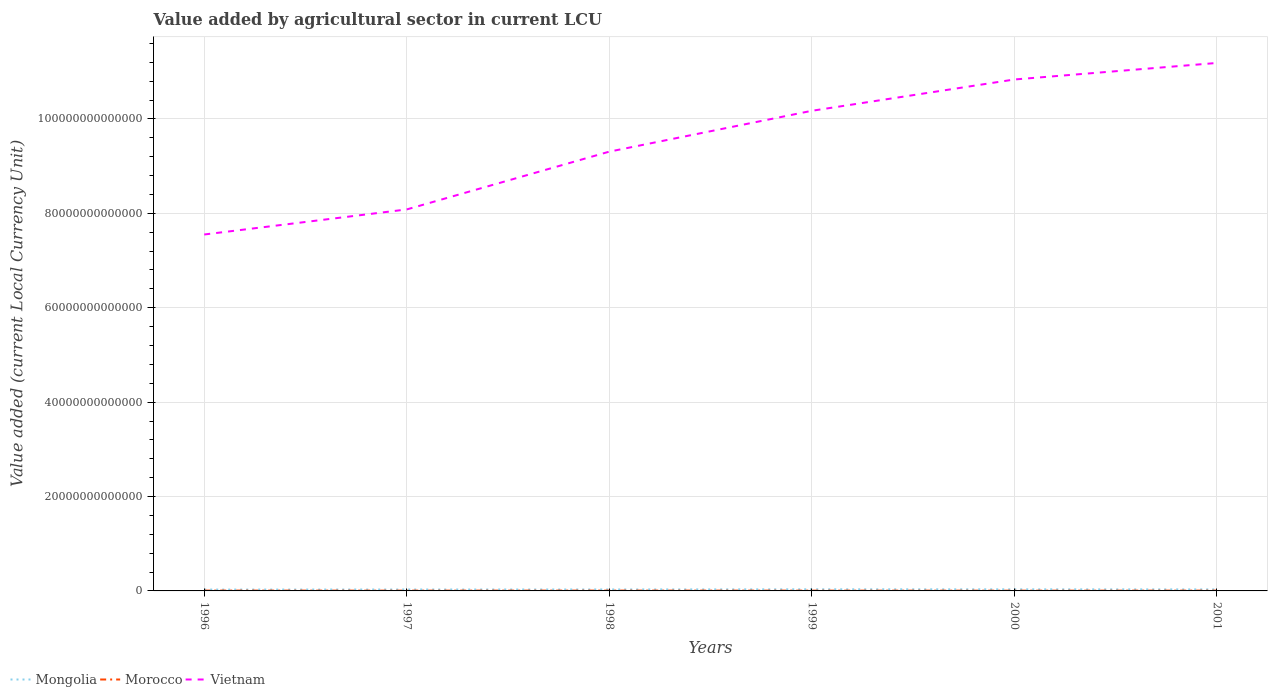Is the number of lines equal to the number of legend labels?
Ensure brevity in your answer.  Yes. Across all years, what is the maximum value added by agricultural sector in Vietnam?
Your response must be concise. 7.55e+13. What is the total value added by agricultural sector in Morocco in the graph?
Your answer should be compact. -4.54e+09. What is the difference between the highest and the second highest value added by agricultural sector in Mongolia?
Ensure brevity in your answer.  5.85e+1. How many lines are there?
Ensure brevity in your answer.  3. How many years are there in the graph?
Give a very brief answer. 6. What is the difference between two consecutive major ticks on the Y-axis?
Ensure brevity in your answer.  2.00e+13. Are the values on the major ticks of Y-axis written in scientific E-notation?
Your answer should be compact. No. Does the graph contain grids?
Offer a terse response. Yes. Where does the legend appear in the graph?
Provide a succinct answer. Bottom left. How many legend labels are there?
Keep it short and to the point. 3. How are the legend labels stacked?
Your answer should be very brief. Horizontal. What is the title of the graph?
Offer a very short reply. Value added by agricultural sector in current LCU. Does "Solomon Islands" appear as one of the legend labels in the graph?
Offer a terse response. No. What is the label or title of the Y-axis?
Your response must be concise. Value added (current Local Currency Unit). What is the Value added (current Local Currency Unit) in Mongolia in 1996?
Make the answer very short. 2.84e+11. What is the Value added (current Local Currency Unit) in Morocco in 1996?
Offer a very short reply. 7.09e+1. What is the Value added (current Local Currency Unit) of Vietnam in 1996?
Provide a succinct answer. 7.55e+13. What is the Value added (current Local Currency Unit) in Mongolia in 1997?
Provide a short and direct response. 3.01e+11. What is the Value added (current Local Currency Unit) of Morocco in 1997?
Your answer should be compact. 5.81e+1. What is the Value added (current Local Currency Unit) in Vietnam in 1997?
Provide a succinct answer. 8.08e+13. What is the Value added (current Local Currency Unit) of Mongolia in 1998?
Provide a short and direct response. 3.07e+11. What is the Value added (current Local Currency Unit) in Morocco in 1998?
Provide a short and direct response. 6.89e+1. What is the Value added (current Local Currency Unit) of Vietnam in 1998?
Your response must be concise. 9.31e+13. What is the Value added (current Local Currency Unit) in Mongolia in 1999?
Your answer should be very brief. 3.43e+11. What is the Value added (current Local Currency Unit) of Morocco in 1999?
Give a very brief answer. 6.03e+1. What is the Value added (current Local Currency Unit) of Vietnam in 1999?
Your answer should be very brief. 1.02e+14. What is the Value added (current Local Currency Unit) in Mongolia in 2000?
Give a very brief answer. 3.36e+11. What is the Value added (current Local Currency Unit) in Morocco in 2000?
Provide a succinct answer. 5.22e+1. What is the Value added (current Local Currency Unit) in Vietnam in 2000?
Ensure brevity in your answer.  1.08e+14. What is the Value added (current Local Currency Unit) of Mongolia in 2001?
Keep it short and to the point. 3.20e+11. What is the Value added (current Local Currency Unit) of Morocco in 2001?
Your response must be concise. 6.27e+1. What is the Value added (current Local Currency Unit) in Vietnam in 2001?
Provide a short and direct response. 1.12e+14. Across all years, what is the maximum Value added (current Local Currency Unit) of Mongolia?
Make the answer very short. 3.43e+11. Across all years, what is the maximum Value added (current Local Currency Unit) in Morocco?
Ensure brevity in your answer.  7.09e+1. Across all years, what is the maximum Value added (current Local Currency Unit) in Vietnam?
Offer a very short reply. 1.12e+14. Across all years, what is the minimum Value added (current Local Currency Unit) of Mongolia?
Make the answer very short. 2.84e+11. Across all years, what is the minimum Value added (current Local Currency Unit) of Morocco?
Offer a terse response. 5.22e+1. Across all years, what is the minimum Value added (current Local Currency Unit) of Vietnam?
Give a very brief answer. 7.55e+13. What is the total Value added (current Local Currency Unit) of Mongolia in the graph?
Offer a terse response. 1.89e+12. What is the total Value added (current Local Currency Unit) in Morocco in the graph?
Keep it short and to the point. 3.73e+11. What is the total Value added (current Local Currency Unit) of Vietnam in the graph?
Provide a short and direct response. 5.71e+14. What is the difference between the Value added (current Local Currency Unit) in Mongolia in 1996 and that in 1997?
Offer a very short reply. -1.68e+1. What is the difference between the Value added (current Local Currency Unit) of Morocco in 1996 and that in 1997?
Offer a terse response. 1.28e+1. What is the difference between the Value added (current Local Currency Unit) of Vietnam in 1996 and that in 1997?
Offer a terse response. -5.31e+12. What is the difference between the Value added (current Local Currency Unit) of Mongolia in 1996 and that in 1998?
Your answer should be compact. -2.27e+1. What is the difference between the Value added (current Local Currency Unit) of Morocco in 1996 and that in 1998?
Give a very brief answer. 1.99e+09. What is the difference between the Value added (current Local Currency Unit) of Vietnam in 1996 and that in 1998?
Make the answer very short. -1.76e+13. What is the difference between the Value added (current Local Currency Unit) in Mongolia in 1996 and that in 1999?
Your answer should be compact. -5.85e+1. What is the difference between the Value added (current Local Currency Unit) in Morocco in 1996 and that in 1999?
Keep it short and to the point. 1.06e+1. What is the difference between the Value added (current Local Currency Unit) in Vietnam in 1996 and that in 1999?
Your answer should be very brief. -2.62e+13. What is the difference between the Value added (current Local Currency Unit) of Mongolia in 1996 and that in 2000?
Provide a short and direct response. -5.17e+1. What is the difference between the Value added (current Local Currency Unit) in Morocco in 1996 and that in 2000?
Provide a succinct answer. 1.87e+1. What is the difference between the Value added (current Local Currency Unit) of Vietnam in 1996 and that in 2000?
Make the answer very short. -3.28e+13. What is the difference between the Value added (current Local Currency Unit) of Mongolia in 1996 and that in 2001?
Offer a terse response. -3.57e+1. What is the difference between the Value added (current Local Currency Unit) of Morocco in 1996 and that in 2001?
Offer a terse response. 8.23e+09. What is the difference between the Value added (current Local Currency Unit) of Vietnam in 1996 and that in 2001?
Offer a terse response. -3.63e+13. What is the difference between the Value added (current Local Currency Unit) in Mongolia in 1997 and that in 1998?
Your response must be concise. -5.90e+09. What is the difference between the Value added (current Local Currency Unit) of Morocco in 1997 and that in 1998?
Make the answer very short. -1.08e+1. What is the difference between the Value added (current Local Currency Unit) in Vietnam in 1997 and that in 1998?
Your answer should be compact. -1.22e+13. What is the difference between the Value added (current Local Currency Unit) in Mongolia in 1997 and that in 1999?
Give a very brief answer. -4.18e+1. What is the difference between the Value added (current Local Currency Unit) of Morocco in 1997 and that in 1999?
Make the answer very short. -2.15e+09. What is the difference between the Value added (current Local Currency Unit) in Vietnam in 1997 and that in 1999?
Your answer should be very brief. -2.09e+13. What is the difference between the Value added (current Local Currency Unit) of Mongolia in 1997 and that in 2000?
Give a very brief answer. -3.49e+1. What is the difference between the Value added (current Local Currency Unit) of Morocco in 1997 and that in 2000?
Ensure brevity in your answer.  5.90e+09. What is the difference between the Value added (current Local Currency Unit) of Vietnam in 1997 and that in 2000?
Offer a very short reply. -2.75e+13. What is the difference between the Value added (current Local Currency Unit) of Mongolia in 1997 and that in 2001?
Offer a very short reply. -1.90e+1. What is the difference between the Value added (current Local Currency Unit) of Morocco in 1997 and that in 2001?
Your answer should be very brief. -4.54e+09. What is the difference between the Value added (current Local Currency Unit) of Vietnam in 1997 and that in 2001?
Your answer should be very brief. -3.10e+13. What is the difference between the Value added (current Local Currency Unit) of Mongolia in 1998 and that in 1999?
Ensure brevity in your answer.  -3.59e+1. What is the difference between the Value added (current Local Currency Unit) of Morocco in 1998 and that in 1999?
Offer a terse response. 8.63e+09. What is the difference between the Value added (current Local Currency Unit) of Vietnam in 1998 and that in 1999?
Ensure brevity in your answer.  -8.66e+12. What is the difference between the Value added (current Local Currency Unit) in Mongolia in 1998 and that in 2000?
Your response must be concise. -2.90e+1. What is the difference between the Value added (current Local Currency Unit) of Morocco in 1998 and that in 2000?
Your answer should be very brief. 1.67e+1. What is the difference between the Value added (current Local Currency Unit) of Vietnam in 1998 and that in 2000?
Keep it short and to the point. -1.53e+13. What is the difference between the Value added (current Local Currency Unit) of Mongolia in 1998 and that in 2001?
Provide a short and direct response. -1.31e+1. What is the difference between the Value added (current Local Currency Unit) in Morocco in 1998 and that in 2001?
Your answer should be compact. 6.24e+09. What is the difference between the Value added (current Local Currency Unit) of Vietnam in 1998 and that in 2001?
Offer a terse response. -1.88e+13. What is the difference between the Value added (current Local Currency Unit) of Mongolia in 1999 and that in 2000?
Provide a short and direct response. 6.84e+09. What is the difference between the Value added (current Local Currency Unit) of Morocco in 1999 and that in 2000?
Your answer should be very brief. 8.05e+09. What is the difference between the Value added (current Local Currency Unit) of Vietnam in 1999 and that in 2000?
Your response must be concise. -6.63e+12. What is the difference between the Value added (current Local Currency Unit) of Mongolia in 1999 and that in 2001?
Provide a succinct answer. 2.28e+1. What is the difference between the Value added (current Local Currency Unit) of Morocco in 1999 and that in 2001?
Offer a terse response. -2.39e+09. What is the difference between the Value added (current Local Currency Unit) of Vietnam in 1999 and that in 2001?
Keep it short and to the point. -1.01e+13. What is the difference between the Value added (current Local Currency Unit) in Mongolia in 2000 and that in 2001?
Provide a short and direct response. 1.60e+1. What is the difference between the Value added (current Local Currency Unit) of Morocco in 2000 and that in 2001?
Provide a succinct answer. -1.04e+1. What is the difference between the Value added (current Local Currency Unit) in Vietnam in 2000 and that in 2001?
Make the answer very short. -3.50e+12. What is the difference between the Value added (current Local Currency Unit) of Mongolia in 1996 and the Value added (current Local Currency Unit) of Morocco in 1997?
Make the answer very short. 2.26e+11. What is the difference between the Value added (current Local Currency Unit) in Mongolia in 1996 and the Value added (current Local Currency Unit) in Vietnam in 1997?
Your answer should be compact. -8.05e+13. What is the difference between the Value added (current Local Currency Unit) of Morocco in 1996 and the Value added (current Local Currency Unit) of Vietnam in 1997?
Ensure brevity in your answer.  -8.08e+13. What is the difference between the Value added (current Local Currency Unit) of Mongolia in 1996 and the Value added (current Local Currency Unit) of Morocco in 1998?
Offer a terse response. 2.15e+11. What is the difference between the Value added (current Local Currency Unit) in Mongolia in 1996 and the Value added (current Local Currency Unit) in Vietnam in 1998?
Provide a succinct answer. -9.28e+13. What is the difference between the Value added (current Local Currency Unit) of Morocco in 1996 and the Value added (current Local Currency Unit) of Vietnam in 1998?
Offer a terse response. -9.30e+13. What is the difference between the Value added (current Local Currency Unit) of Mongolia in 1996 and the Value added (current Local Currency Unit) of Morocco in 1999?
Make the answer very short. 2.24e+11. What is the difference between the Value added (current Local Currency Unit) of Mongolia in 1996 and the Value added (current Local Currency Unit) of Vietnam in 1999?
Your response must be concise. -1.01e+14. What is the difference between the Value added (current Local Currency Unit) of Morocco in 1996 and the Value added (current Local Currency Unit) of Vietnam in 1999?
Offer a very short reply. -1.02e+14. What is the difference between the Value added (current Local Currency Unit) of Mongolia in 1996 and the Value added (current Local Currency Unit) of Morocco in 2000?
Offer a terse response. 2.32e+11. What is the difference between the Value added (current Local Currency Unit) of Mongolia in 1996 and the Value added (current Local Currency Unit) of Vietnam in 2000?
Provide a succinct answer. -1.08e+14. What is the difference between the Value added (current Local Currency Unit) of Morocco in 1996 and the Value added (current Local Currency Unit) of Vietnam in 2000?
Keep it short and to the point. -1.08e+14. What is the difference between the Value added (current Local Currency Unit) in Mongolia in 1996 and the Value added (current Local Currency Unit) in Morocco in 2001?
Offer a terse response. 2.21e+11. What is the difference between the Value added (current Local Currency Unit) of Mongolia in 1996 and the Value added (current Local Currency Unit) of Vietnam in 2001?
Keep it short and to the point. -1.12e+14. What is the difference between the Value added (current Local Currency Unit) in Morocco in 1996 and the Value added (current Local Currency Unit) in Vietnam in 2001?
Make the answer very short. -1.12e+14. What is the difference between the Value added (current Local Currency Unit) of Mongolia in 1997 and the Value added (current Local Currency Unit) of Morocco in 1998?
Give a very brief answer. 2.32e+11. What is the difference between the Value added (current Local Currency Unit) in Mongolia in 1997 and the Value added (current Local Currency Unit) in Vietnam in 1998?
Provide a succinct answer. -9.28e+13. What is the difference between the Value added (current Local Currency Unit) of Morocco in 1997 and the Value added (current Local Currency Unit) of Vietnam in 1998?
Give a very brief answer. -9.30e+13. What is the difference between the Value added (current Local Currency Unit) in Mongolia in 1997 and the Value added (current Local Currency Unit) in Morocco in 1999?
Make the answer very short. 2.40e+11. What is the difference between the Value added (current Local Currency Unit) in Mongolia in 1997 and the Value added (current Local Currency Unit) in Vietnam in 1999?
Provide a succinct answer. -1.01e+14. What is the difference between the Value added (current Local Currency Unit) in Morocco in 1997 and the Value added (current Local Currency Unit) in Vietnam in 1999?
Your response must be concise. -1.02e+14. What is the difference between the Value added (current Local Currency Unit) in Mongolia in 1997 and the Value added (current Local Currency Unit) in Morocco in 2000?
Make the answer very short. 2.49e+11. What is the difference between the Value added (current Local Currency Unit) of Mongolia in 1997 and the Value added (current Local Currency Unit) of Vietnam in 2000?
Ensure brevity in your answer.  -1.08e+14. What is the difference between the Value added (current Local Currency Unit) in Morocco in 1997 and the Value added (current Local Currency Unit) in Vietnam in 2000?
Your response must be concise. -1.08e+14. What is the difference between the Value added (current Local Currency Unit) in Mongolia in 1997 and the Value added (current Local Currency Unit) in Morocco in 2001?
Provide a succinct answer. 2.38e+11. What is the difference between the Value added (current Local Currency Unit) in Mongolia in 1997 and the Value added (current Local Currency Unit) in Vietnam in 2001?
Offer a terse response. -1.12e+14. What is the difference between the Value added (current Local Currency Unit) of Morocco in 1997 and the Value added (current Local Currency Unit) of Vietnam in 2001?
Offer a terse response. -1.12e+14. What is the difference between the Value added (current Local Currency Unit) in Mongolia in 1998 and the Value added (current Local Currency Unit) in Morocco in 1999?
Provide a succinct answer. 2.46e+11. What is the difference between the Value added (current Local Currency Unit) of Mongolia in 1998 and the Value added (current Local Currency Unit) of Vietnam in 1999?
Provide a succinct answer. -1.01e+14. What is the difference between the Value added (current Local Currency Unit) in Morocco in 1998 and the Value added (current Local Currency Unit) in Vietnam in 1999?
Your answer should be very brief. -1.02e+14. What is the difference between the Value added (current Local Currency Unit) of Mongolia in 1998 and the Value added (current Local Currency Unit) of Morocco in 2000?
Give a very brief answer. 2.54e+11. What is the difference between the Value added (current Local Currency Unit) in Mongolia in 1998 and the Value added (current Local Currency Unit) in Vietnam in 2000?
Your response must be concise. -1.08e+14. What is the difference between the Value added (current Local Currency Unit) of Morocco in 1998 and the Value added (current Local Currency Unit) of Vietnam in 2000?
Give a very brief answer. -1.08e+14. What is the difference between the Value added (current Local Currency Unit) in Mongolia in 1998 and the Value added (current Local Currency Unit) in Morocco in 2001?
Provide a short and direct response. 2.44e+11. What is the difference between the Value added (current Local Currency Unit) in Mongolia in 1998 and the Value added (current Local Currency Unit) in Vietnam in 2001?
Offer a very short reply. -1.12e+14. What is the difference between the Value added (current Local Currency Unit) of Morocco in 1998 and the Value added (current Local Currency Unit) of Vietnam in 2001?
Offer a very short reply. -1.12e+14. What is the difference between the Value added (current Local Currency Unit) of Mongolia in 1999 and the Value added (current Local Currency Unit) of Morocco in 2000?
Your response must be concise. 2.90e+11. What is the difference between the Value added (current Local Currency Unit) of Mongolia in 1999 and the Value added (current Local Currency Unit) of Vietnam in 2000?
Keep it short and to the point. -1.08e+14. What is the difference between the Value added (current Local Currency Unit) in Morocco in 1999 and the Value added (current Local Currency Unit) in Vietnam in 2000?
Provide a succinct answer. -1.08e+14. What is the difference between the Value added (current Local Currency Unit) in Mongolia in 1999 and the Value added (current Local Currency Unit) in Morocco in 2001?
Keep it short and to the point. 2.80e+11. What is the difference between the Value added (current Local Currency Unit) in Mongolia in 1999 and the Value added (current Local Currency Unit) in Vietnam in 2001?
Ensure brevity in your answer.  -1.12e+14. What is the difference between the Value added (current Local Currency Unit) of Morocco in 1999 and the Value added (current Local Currency Unit) of Vietnam in 2001?
Your answer should be very brief. -1.12e+14. What is the difference between the Value added (current Local Currency Unit) in Mongolia in 2000 and the Value added (current Local Currency Unit) in Morocco in 2001?
Offer a very short reply. 2.73e+11. What is the difference between the Value added (current Local Currency Unit) of Mongolia in 2000 and the Value added (current Local Currency Unit) of Vietnam in 2001?
Offer a very short reply. -1.12e+14. What is the difference between the Value added (current Local Currency Unit) in Morocco in 2000 and the Value added (current Local Currency Unit) in Vietnam in 2001?
Give a very brief answer. -1.12e+14. What is the average Value added (current Local Currency Unit) of Mongolia per year?
Keep it short and to the point. 3.15e+11. What is the average Value added (current Local Currency Unit) of Morocco per year?
Provide a short and direct response. 6.22e+1. What is the average Value added (current Local Currency Unit) of Vietnam per year?
Make the answer very short. 9.52e+13. In the year 1996, what is the difference between the Value added (current Local Currency Unit) in Mongolia and Value added (current Local Currency Unit) in Morocco?
Your answer should be compact. 2.13e+11. In the year 1996, what is the difference between the Value added (current Local Currency Unit) of Mongolia and Value added (current Local Currency Unit) of Vietnam?
Offer a very short reply. -7.52e+13. In the year 1996, what is the difference between the Value added (current Local Currency Unit) of Morocco and Value added (current Local Currency Unit) of Vietnam?
Your response must be concise. -7.54e+13. In the year 1997, what is the difference between the Value added (current Local Currency Unit) in Mongolia and Value added (current Local Currency Unit) in Morocco?
Make the answer very short. 2.43e+11. In the year 1997, what is the difference between the Value added (current Local Currency Unit) of Mongolia and Value added (current Local Currency Unit) of Vietnam?
Provide a short and direct response. -8.05e+13. In the year 1997, what is the difference between the Value added (current Local Currency Unit) of Morocco and Value added (current Local Currency Unit) of Vietnam?
Give a very brief answer. -8.08e+13. In the year 1998, what is the difference between the Value added (current Local Currency Unit) of Mongolia and Value added (current Local Currency Unit) of Morocco?
Provide a succinct answer. 2.38e+11. In the year 1998, what is the difference between the Value added (current Local Currency Unit) of Mongolia and Value added (current Local Currency Unit) of Vietnam?
Ensure brevity in your answer.  -9.28e+13. In the year 1998, what is the difference between the Value added (current Local Currency Unit) of Morocco and Value added (current Local Currency Unit) of Vietnam?
Provide a short and direct response. -9.30e+13. In the year 1999, what is the difference between the Value added (current Local Currency Unit) of Mongolia and Value added (current Local Currency Unit) of Morocco?
Your response must be concise. 2.82e+11. In the year 1999, what is the difference between the Value added (current Local Currency Unit) in Mongolia and Value added (current Local Currency Unit) in Vietnam?
Make the answer very short. -1.01e+14. In the year 1999, what is the difference between the Value added (current Local Currency Unit) of Morocco and Value added (current Local Currency Unit) of Vietnam?
Keep it short and to the point. -1.02e+14. In the year 2000, what is the difference between the Value added (current Local Currency Unit) of Mongolia and Value added (current Local Currency Unit) of Morocco?
Your response must be concise. 2.83e+11. In the year 2000, what is the difference between the Value added (current Local Currency Unit) of Mongolia and Value added (current Local Currency Unit) of Vietnam?
Offer a very short reply. -1.08e+14. In the year 2000, what is the difference between the Value added (current Local Currency Unit) in Morocco and Value added (current Local Currency Unit) in Vietnam?
Make the answer very short. -1.08e+14. In the year 2001, what is the difference between the Value added (current Local Currency Unit) of Mongolia and Value added (current Local Currency Unit) of Morocco?
Your answer should be very brief. 2.57e+11. In the year 2001, what is the difference between the Value added (current Local Currency Unit) of Mongolia and Value added (current Local Currency Unit) of Vietnam?
Ensure brevity in your answer.  -1.12e+14. In the year 2001, what is the difference between the Value added (current Local Currency Unit) of Morocco and Value added (current Local Currency Unit) of Vietnam?
Give a very brief answer. -1.12e+14. What is the ratio of the Value added (current Local Currency Unit) of Mongolia in 1996 to that in 1997?
Make the answer very short. 0.94. What is the ratio of the Value added (current Local Currency Unit) in Morocco in 1996 to that in 1997?
Your answer should be compact. 1.22. What is the ratio of the Value added (current Local Currency Unit) in Vietnam in 1996 to that in 1997?
Offer a terse response. 0.93. What is the ratio of the Value added (current Local Currency Unit) in Mongolia in 1996 to that in 1998?
Your response must be concise. 0.93. What is the ratio of the Value added (current Local Currency Unit) of Morocco in 1996 to that in 1998?
Your answer should be compact. 1.03. What is the ratio of the Value added (current Local Currency Unit) of Vietnam in 1996 to that in 1998?
Give a very brief answer. 0.81. What is the ratio of the Value added (current Local Currency Unit) in Mongolia in 1996 to that in 1999?
Your answer should be very brief. 0.83. What is the ratio of the Value added (current Local Currency Unit) of Morocco in 1996 to that in 1999?
Ensure brevity in your answer.  1.18. What is the ratio of the Value added (current Local Currency Unit) of Vietnam in 1996 to that in 1999?
Keep it short and to the point. 0.74. What is the ratio of the Value added (current Local Currency Unit) of Mongolia in 1996 to that in 2000?
Offer a terse response. 0.85. What is the ratio of the Value added (current Local Currency Unit) of Morocco in 1996 to that in 2000?
Provide a succinct answer. 1.36. What is the ratio of the Value added (current Local Currency Unit) in Vietnam in 1996 to that in 2000?
Offer a very short reply. 0.7. What is the ratio of the Value added (current Local Currency Unit) of Mongolia in 1996 to that in 2001?
Your response must be concise. 0.89. What is the ratio of the Value added (current Local Currency Unit) of Morocco in 1996 to that in 2001?
Your answer should be very brief. 1.13. What is the ratio of the Value added (current Local Currency Unit) in Vietnam in 1996 to that in 2001?
Offer a very short reply. 0.68. What is the ratio of the Value added (current Local Currency Unit) of Mongolia in 1997 to that in 1998?
Offer a very short reply. 0.98. What is the ratio of the Value added (current Local Currency Unit) of Morocco in 1997 to that in 1998?
Give a very brief answer. 0.84. What is the ratio of the Value added (current Local Currency Unit) in Vietnam in 1997 to that in 1998?
Your response must be concise. 0.87. What is the ratio of the Value added (current Local Currency Unit) of Mongolia in 1997 to that in 1999?
Your answer should be very brief. 0.88. What is the ratio of the Value added (current Local Currency Unit) in Morocco in 1997 to that in 1999?
Provide a succinct answer. 0.96. What is the ratio of the Value added (current Local Currency Unit) of Vietnam in 1997 to that in 1999?
Your response must be concise. 0.79. What is the ratio of the Value added (current Local Currency Unit) of Mongolia in 1997 to that in 2000?
Give a very brief answer. 0.9. What is the ratio of the Value added (current Local Currency Unit) in Morocco in 1997 to that in 2000?
Your response must be concise. 1.11. What is the ratio of the Value added (current Local Currency Unit) of Vietnam in 1997 to that in 2000?
Your answer should be very brief. 0.75. What is the ratio of the Value added (current Local Currency Unit) of Mongolia in 1997 to that in 2001?
Offer a terse response. 0.94. What is the ratio of the Value added (current Local Currency Unit) in Morocco in 1997 to that in 2001?
Provide a short and direct response. 0.93. What is the ratio of the Value added (current Local Currency Unit) of Vietnam in 1997 to that in 2001?
Provide a short and direct response. 0.72. What is the ratio of the Value added (current Local Currency Unit) in Mongolia in 1998 to that in 1999?
Ensure brevity in your answer.  0.9. What is the ratio of the Value added (current Local Currency Unit) of Morocco in 1998 to that in 1999?
Ensure brevity in your answer.  1.14. What is the ratio of the Value added (current Local Currency Unit) of Vietnam in 1998 to that in 1999?
Keep it short and to the point. 0.91. What is the ratio of the Value added (current Local Currency Unit) in Mongolia in 1998 to that in 2000?
Make the answer very short. 0.91. What is the ratio of the Value added (current Local Currency Unit) of Morocco in 1998 to that in 2000?
Your answer should be compact. 1.32. What is the ratio of the Value added (current Local Currency Unit) of Vietnam in 1998 to that in 2000?
Your response must be concise. 0.86. What is the ratio of the Value added (current Local Currency Unit) in Mongolia in 1998 to that in 2001?
Provide a short and direct response. 0.96. What is the ratio of the Value added (current Local Currency Unit) of Morocco in 1998 to that in 2001?
Give a very brief answer. 1.1. What is the ratio of the Value added (current Local Currency Unit) of Vietnam in 1998 to that in 2001?
Offer a terse response. 0.83. What is the ratio of the Value added (current Local Currency Unit) of Mongolia in 1999 to that in 2000?
Give a very brief answer. 1.02. What is the ratio of the Value added (current Local Currency Unit) in Morocco in 1999 to that in 2000?
Your response must be concise. 1.15. What is the ratio of the Value added (current Local Currency Unit) in Vietnam in 1999 to that in 2000?
Give a very brief answer. 0.94. What is the ratio of the Value added (current Local Currency Unit) of Mongolia in 1999 to that in 2001?
Your answer should be very brief. 1.07. What is the ratio of the Value added (current Local Currency Unit) in Morocco in 1999 to that in 2001?
Ensure brevity in your answer.  0.96. What is the ratio of the Value added (current Local Currency Unit) of Vietnam in 1999 to that in 2001?
Your answer should be very brief. 0.91. What is the ratio of the Value added (current Local Currency Unit) in Morocco in 2000 to that in 2001?
Ensure brevity in your answer.  0.83. What is the ratio of the Value added (current Local Currency Unit) in Vietnam in 2000 to that in 2001?
Provide a short and direct response. 0.97. What is the difference between the highest and the second highest Value added (current Local Currency Unit) of Mongolia?
Make the answer very short. 6.84e+09. What is the difference between the highest and the second highest Value added (current Local Currency Unit) of Morocco?
Your answer should be compact. 1.99e+09. What is the difference between the highest and the second highest Value added (current Local Currency Unit) of Vietnam?
Offer a very short reply. 3.50e+12. What is the difference between the highest and the lowest Value added (current Local Currency Unit) in Mongolia?
Offer a terse response. 5.85e+1. What is the difference between the highest and the lowest Value added (current Local Currency Unit) of Morocco?
Your answer should be compact. 1.87e+1. What is the difference between the highest and the lowest Value added (current Local Currency Unit) in Vietnam?
Your response must be concise. 3.63e+13. 